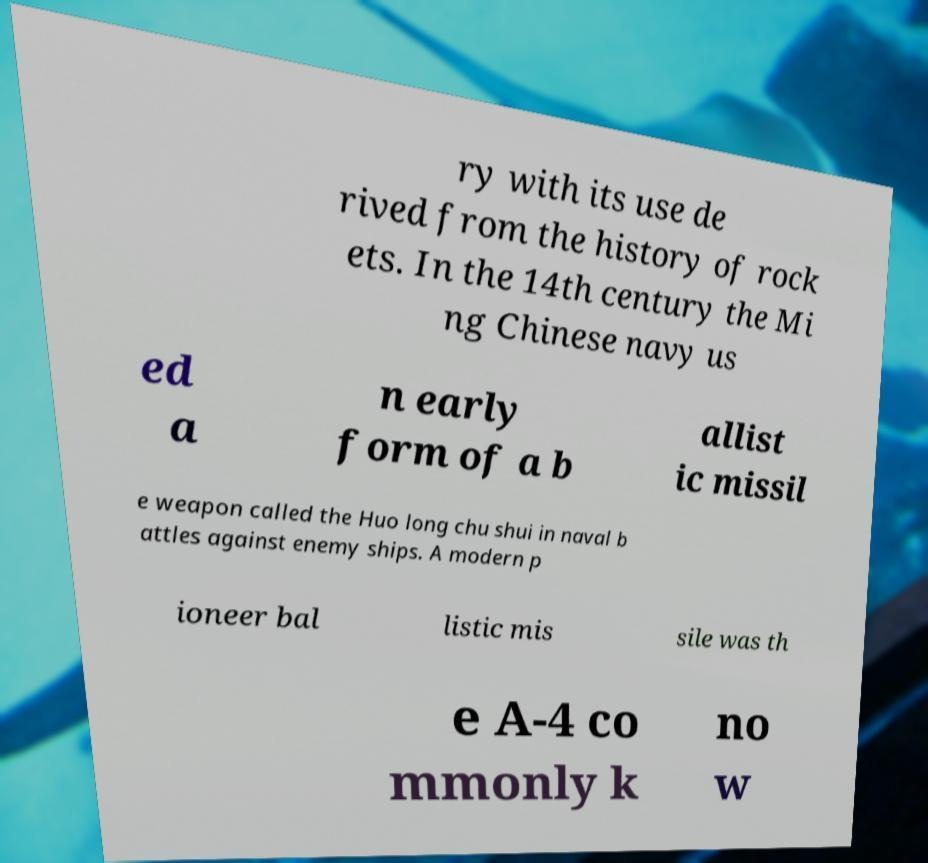Could you assist in decoding the text presented in this image and type it out clearly? ry with its use de rived from the history of rock ets. In the 14th century the Mi ng Chinese navy us ed a n early form of a b allist ic missil e weapon called the Huo long chu shui in naval b attles against enemy ships. A modern p ioneer bal listic mis sile was th e A-4 co mmonly k no w 